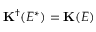<formula> <loc_0><loc_0><loc_500><loc_500>K ^ { \dagger } ( E ^ { * } ) = K ( E )</formula> 